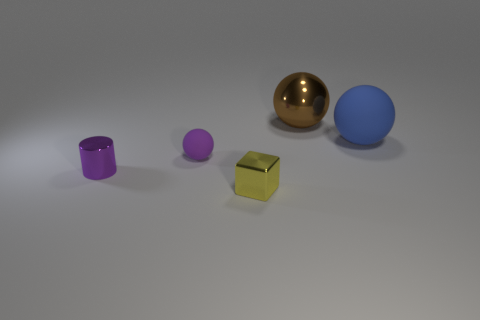Is the number of big blue balls behind the tiny purple matte object greater than the number of brown shiny balls?
Give a very brief answer. No. What number of rubber objects are small green cylinders or tiny yellow things?
Give a very brief answer. 0. What is the size of the thing that is to the left of the brown shiny ball and behind the purple metallic thing?
Give a very brief answer. Small. Is there a purple matte thing that is to the left of the large sphere that is on the right side of the big brown metallic sphere?
Your response must be concise. Yes. There is a large rubber thing; how many objects are behind it?
Your answer should be compact. 1. There is a small rubber thing that is the same shape as the big shiny object; what is its color?
Give a very brief answer. Purple. Is the material of the purple object on the left side of the purple ball the same as the blue object behind the cube?
Ensure brevity in your answer.  No. There is a block; does it have the same color as the tiny thing that is behind the tiny cylinder?
Make the answer very short. No. There is a thing that is both left of the metallic ball and behind the small purple metallic cylinder; what is its shape?
Provide a short and direct response. Sphere. How many gray rubber things are there?
Provide a succinct answer. 0. 